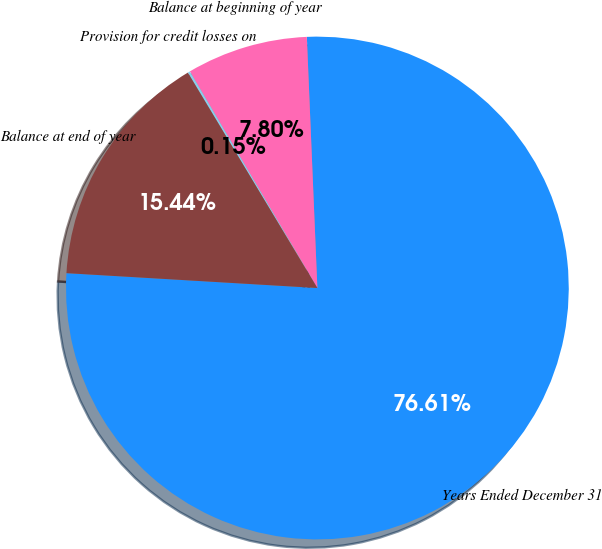Convert chart. <chart><loc_0><loc_0><loc_500><loc_500><pie_chart><fcel>Years Ended December 31<fcel>Balance at beginning of year<fcel>Provision for credit losses on<fcel>Balance at end of year<nl><fcel>76.61%<fcel>7.8%<fcel>0.15%<fcel>15.44%<nl></chart> 